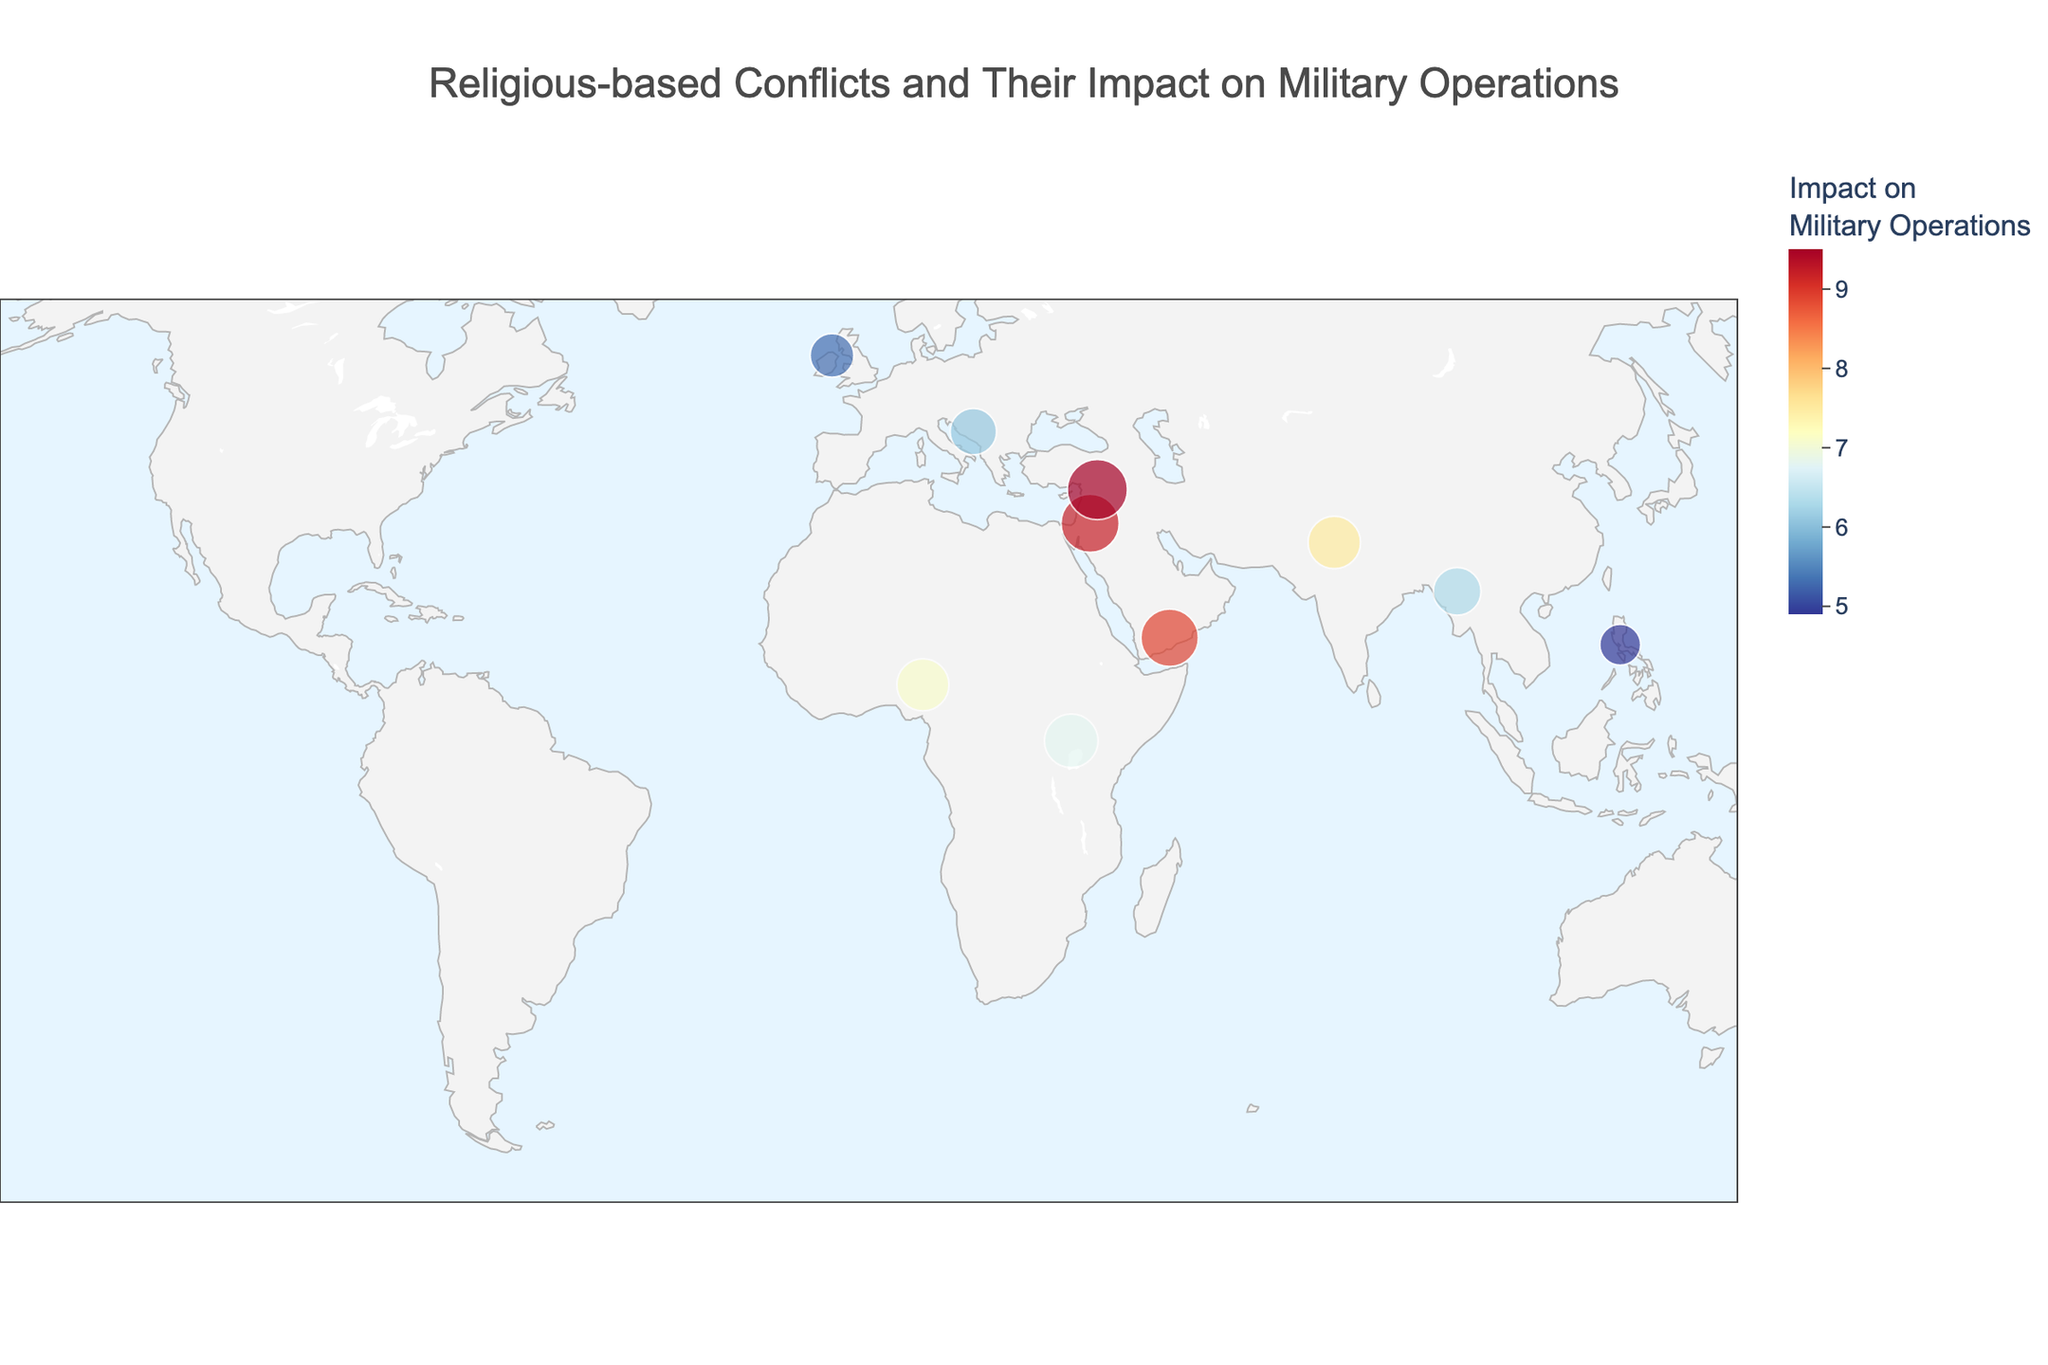What is the title of the plot? The title is located at the top center of the plot. It provides a brief summary of what the plot represents.
Answer: Religious-based Conflicts and Their Impact on Military Operations How many regions are plotted on the map? By counting the number of unique data points or regions annotated on the map, we can determine the total number.
Answer: 10 Which region has the highest intensity of religious conflict? By comparing the sizes of the marked points on the map, the region with the largest marker indicates the highest intensity of religious conflict.
Answer: Syria What's the relationship between the Middle East's religious conflict intensity and its impact on military operations? Check the values for the Middle East in terms of religious conflict intensity and the impact, then compare. The Middle East has a high intensity of 8.5 and a high impact on military operations of 9.2.
Answer: High intensity and high impact How does the impact on military operations in Northern Ireland compare to that in the Middle East? Compare the values of impact on military operations between Northern Ireland and the Middle East. The Middle East has a higher impact value compared to Northern Ireland.
Answer: The Middle East has a higher impact What's the average impact on military operations for regions with a religious conflict intensity above 7.0? First, identify the regions with a religious conflict intensity above 7.0. These regions are Middle East, Sub-Saharan Africa, Syria, and Yemen. Their impacts are 9.2, 6.8, 9.5, and 8.9 respectively. Calculate the average: (9.2 + 6.8 + 9.5 + 8.9) / 4 = 8.6.
Answer: 8.6 Which regions are colored similarly on the map in terms of the impact on military operations? Color similarity on the map indicates similar values for impact on military operations. For example, regions with higher impact values have darker colors, and those with lower impact values have lighter colors. Regions like the Middle East and Syria are similarly colored due to their high impact values.
Answer: The Middle East and Syria Is the geographic spread of high-intensity religious conflicts limited to a specific part of the world? Look at the geographic distribution of regions with large markers representing high intensity. High-intensity conflicts (markers of larger size) are mostly in the Middle East, South Asia, and some parts of Africa.
Answer: No, it's spread across multiple regions How does the geographical representation help in understanding the impact on military operations? The map offers spatial context, showing where regions with varying levels of conflict intensity and military impact are located. This visual aid helps quickly identify areas with significant issues that might need attention. For instance, the concentration of high-impact regions in the Middle East is more apparent.
Answer: Provides spatial context and visual identification 